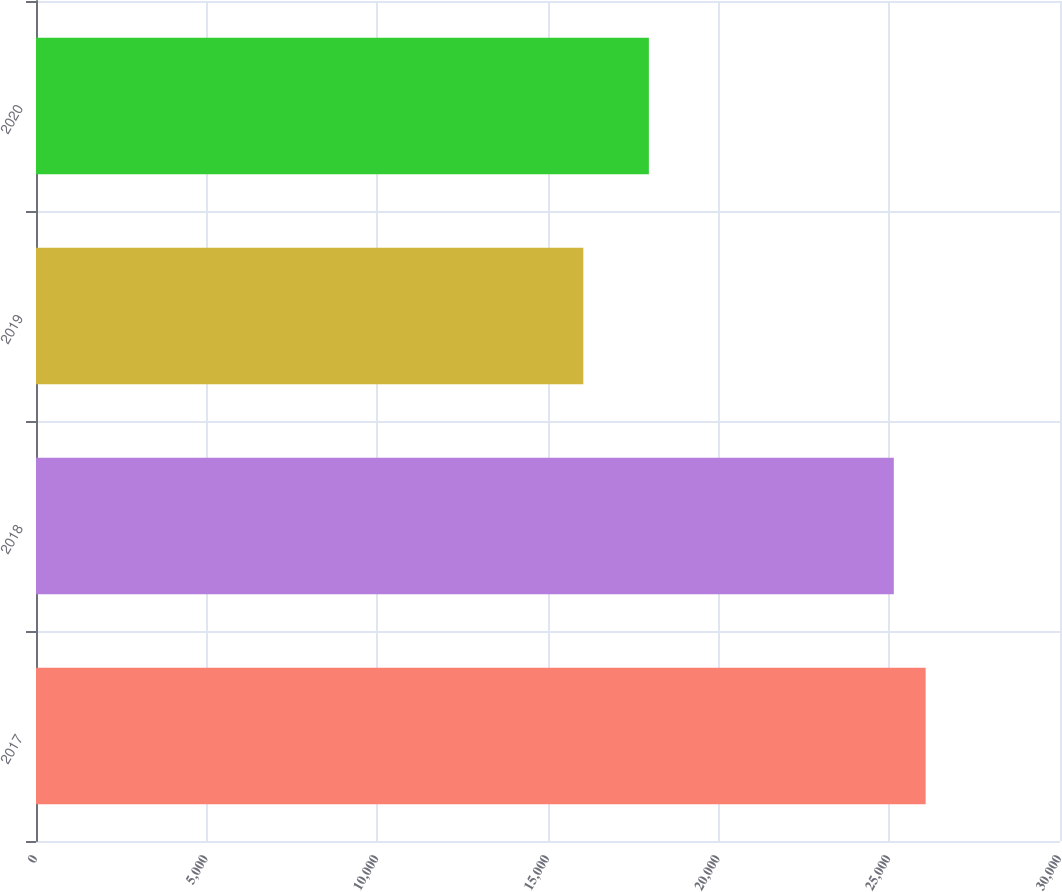Convert chart. <chart><loc_0><loc_0><loc_500><loc_500><bar_chart><fcel>2017<fcel>2018<fcel>2019<fcel>2020<nl><fcel>26063.7<fcel>25131<fcel>16035<fcel>17955<nl></chart> 